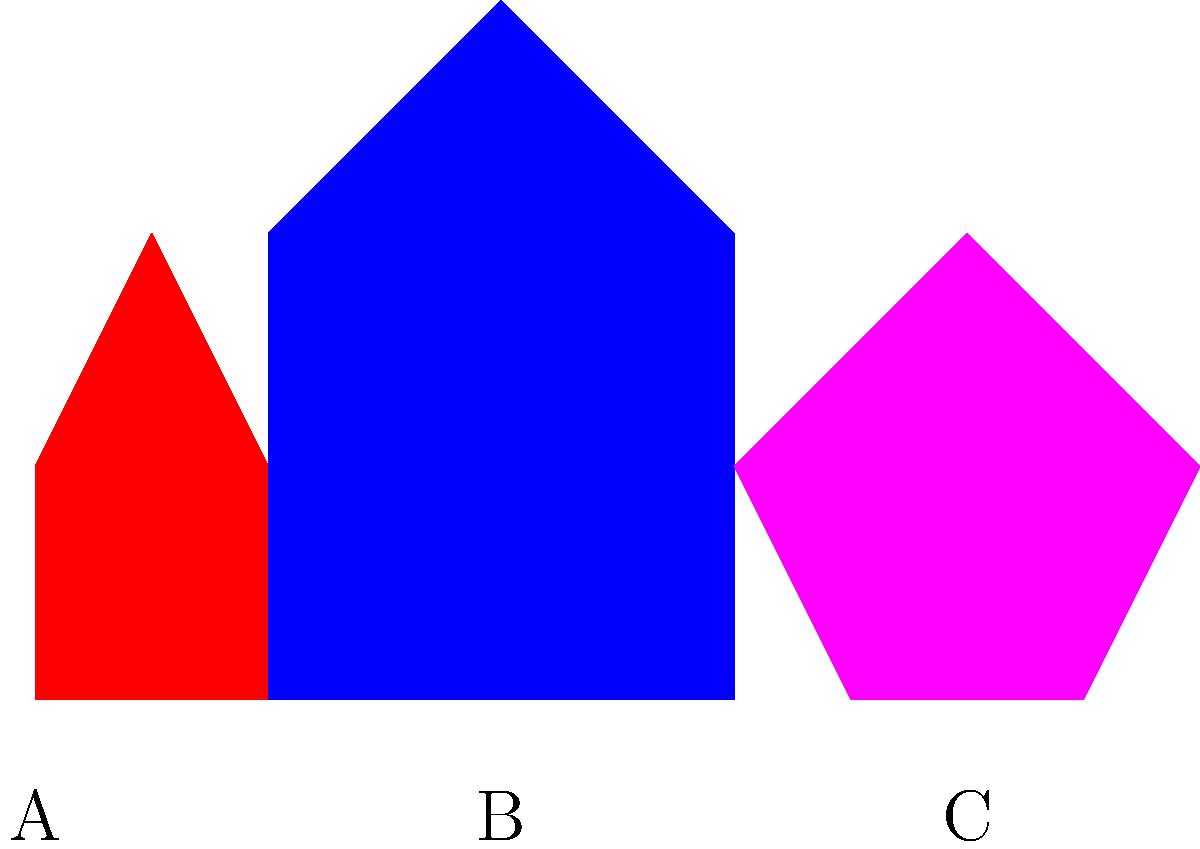Based on the silhouettes shown above, which character is most likely to be Thor, known for his muscular build and signature hammer-wielding stance? To identify Thor among the given silhouettes, we need to analyze each character's shape and stance:

1. Silhouette A (left):
   - Slim figure
   - Symmetrical pose
   - Resembles Iron Man's classic standing position

2. Silhouette B (center):
   - Broad, muscular build
   - Wider stance
   - One arm raised, suggesting a hammer-wielding position
   - Matches Thor's typical posture

3. Silhouette C (right):
   - Slim, agile figure
   - Crouched, ready-to-spring pose
   - Resembles Spider-Man's signature stance

Given Thor's well-known muscular build and hammer-wielding stance, Silhouette B most closely matches his characteristics.
Answer: B 